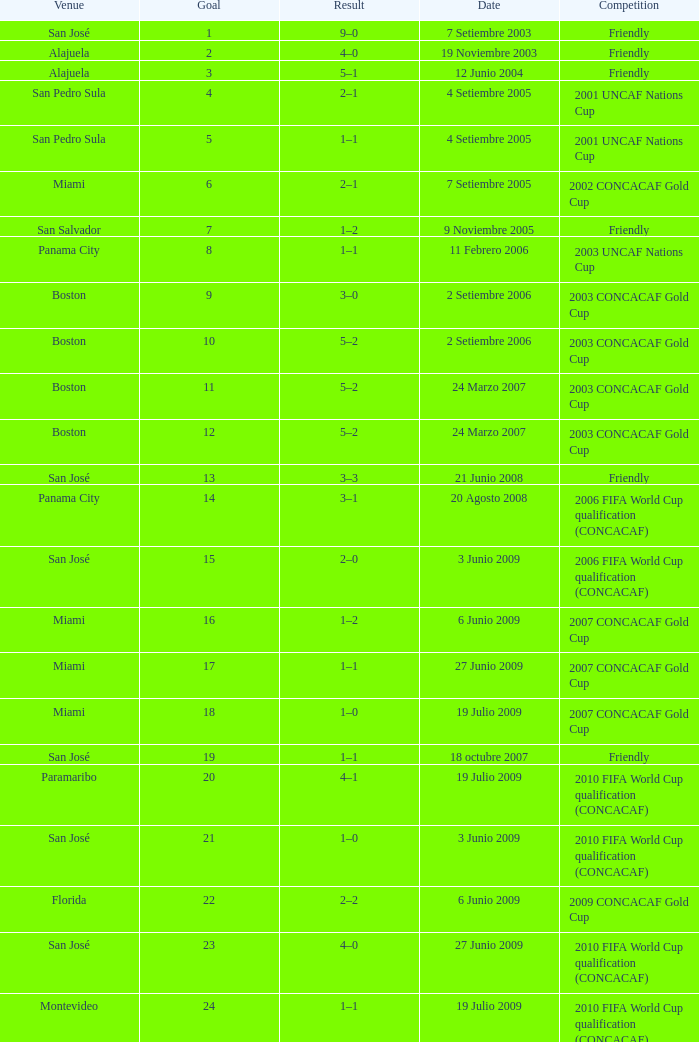At the venue of panama city, on 11 Febrero 2006, how many goals were scored? 1.0. 